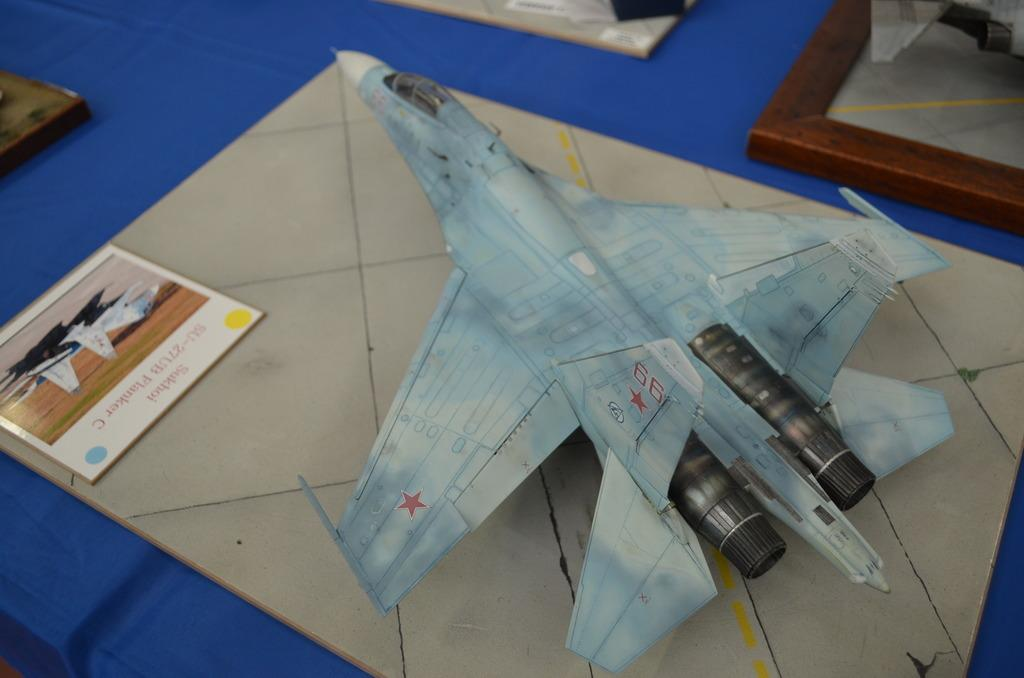What type of toys are visible in the image? There are toy aircrafts in the image. How are the toy aircrafts arranged on the table? The toy aircrafts are on boards in the image. How many boards are on the table? There are four boards on the table. What color is the cloth covering the table? The table is covered with a blue cloth. What type of fowl can be seen walking around on the table in the image? There are no fowl present in the image; it only features toy aircrafts on boards. What religious belief is represented by the objects on the table in the image? There is no indication of any religious belief in the image, as it only contains toy aircrafts, boards, and a blue tablecloth. 